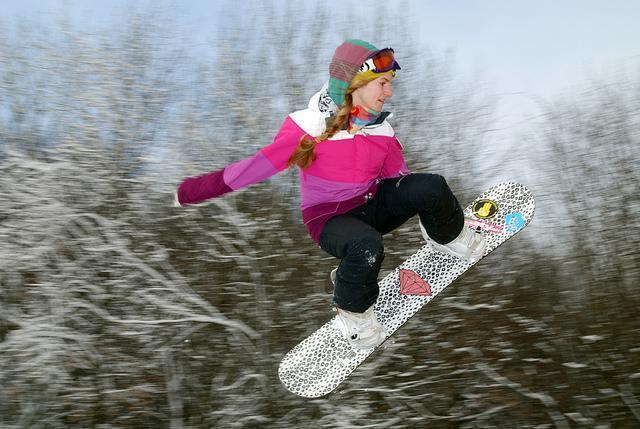How many horses are there in this picture?
Give a very brief answer. 0. 